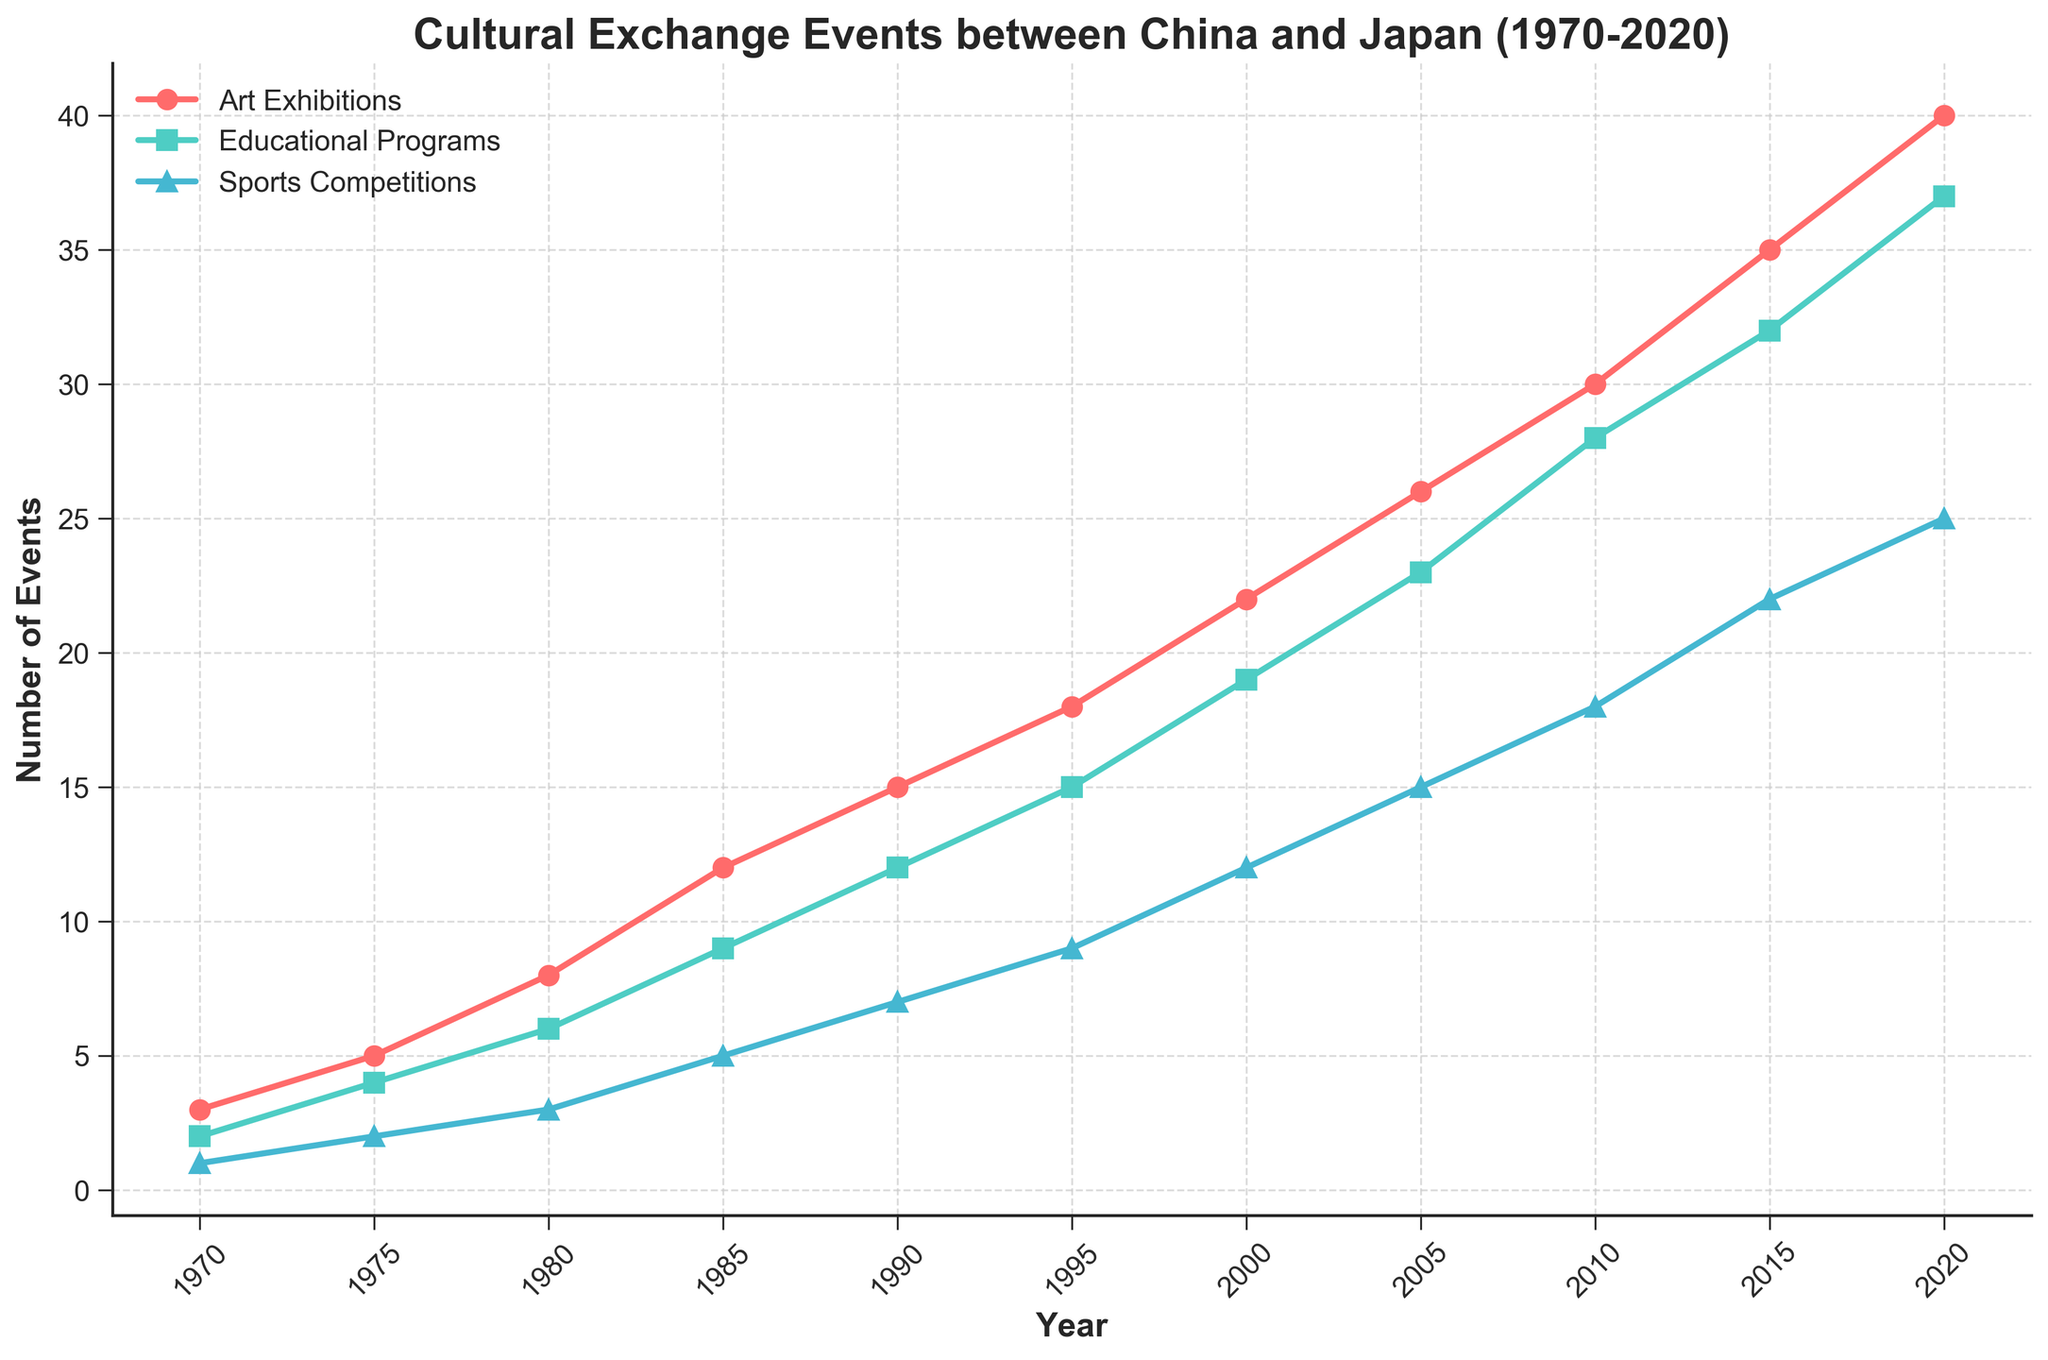What year had the highest number of art exhibitions? The figure shows the progression of art exhibitions from 1970 to 2020. The highest point on the red line corresponds to the year 2020.
Answer: 2020 How many educational programs were there in 1990? Locate 1990 on the x-axis and then read the corresponding value on the green line which represents educational programs.
Answer: 12 Which year had more sports competitions: 1975 or 1980? Compare the values of the blue line at 1975 and 1980. In 1975, there were 2, and in 1980, there were 3.
Answer: 1980 What is the total number of art exhibitions from 2000 to 2020? Add up the values of the red line at the years 2000 (22), 2005 (26), 2010 (30), 2015 (35), and 2020 (40). 22 + 26 + 30 + 35 + 40 = 153
Answer: 153 Did the number of cultural exchange events across all categories increase or decrease from 1970 to 2020? Look at the general trend of all lines (red, green, blue) from 1970 to 2020. All lines show an upward trend indicating an increase in events.
Answer: Increase Which type of event had the greatest increase in number from 1980 to 2000? Calculate the increase for each category: Art Exhibitions increased from 8 to 22 (a change of 14), Educational Programs from 6 to 19 (a change of 13), Sports Competitions from 3 to 12 (a change of 9). Art Exhibitions had the greatest increase.
Answer: Art Exhibitions When did the number of educational programs first exceed 20? Track the green line to see when it crossed the value of 20. It first exceeds 20 in the year 2005.
Answer: 2005 What is the ratio of art exhibitions to sports competitions in 1985? In 1985, the number of art exhibitions is 12, and the number of sports competitions is 5. Therefore, the ratio is 12:5 or 2.4.
Answer: 2.4 What was the difference in the number of educational programs between 2015 and 1995? Locate the number for educational programs in 2015 (32) and 1995 (15). Then, subtract 15 from 32: 32 - 15 = 17.
Answer: 17 